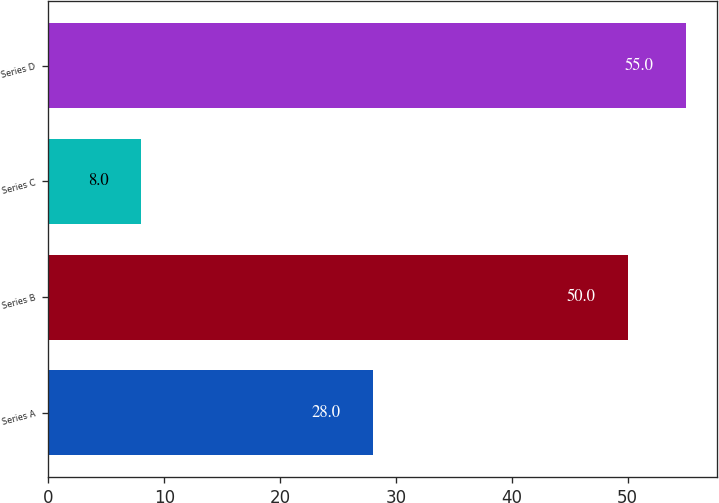Convert chart to OTSL. <chart><loc_0><loc_0><loc_500><loc_500><bar_chart><fcel>Series A<fcel>Series B<fcel>Series C<fcel>Series D<nl><fcel>28<fcel>50<fcel>8<fcel>55<nl></chart> 